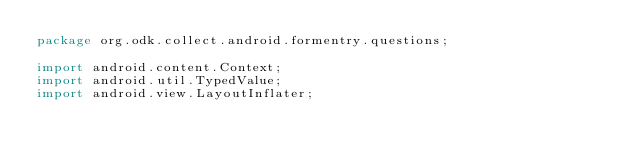<code> <loc_0><loc_0><loc_500><loc_500><_Java_>package org.odk.collect.android.formentry.questions;

import android.content.Context;
import android.util.TypedValue;
import android.view.LayoutInflater;</code> 